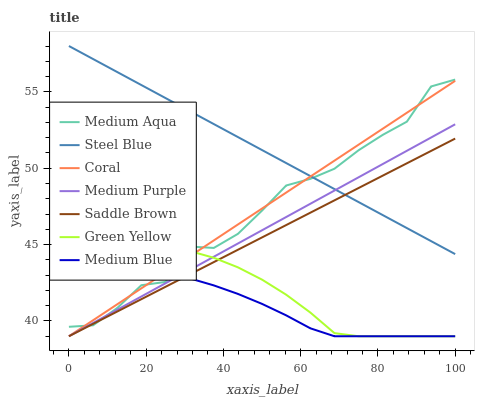Does Medium Blue have the minimum area under the curve?
Answer yes or no. Yes. Does Steel Blue have the maximum area under the curve?
Answer yes or no. Yes. Does Steel Blue have the minimum area under the curve?
Answer yes or no. No. Does Medium Blue have the maximum area under the curve?
Answer yes or no. No. Is Medium Purple the smoothest?
Answer yes or no. Yes. Is Medium Aqua the roughest?
Answer yes or no. Yes. Is Medium Blue the smoothest?
Answer yes or no. No. Is Medium Blue the roughest?
Answer yes or no. No. Does Coral have the lowest value?
Answer yes or no. Yes. Does Steel Blue have the lowest value?
Answer yes or no. No. Does Steel Blue have the highest value?
Answer yes or no. Yes. Does Medium Blue have the highest value?
Answer yes or no. No. Is Medium Blue less than Steel Blue?
Answer yes or no. Yes. Is Steel Blue greater than Green Yellow?
Answer yes or no. Yes. Does Coral intersect Medium Aqua?
Answer yes or no. Yes. Is Coral less than Medium Aqua?
Answer yes or no. No. Is Coral greater than Medium Aqua?
Answer yes or no. No. Does Medium Blue intersect Steel Blue?
Answer yes or no. No. 